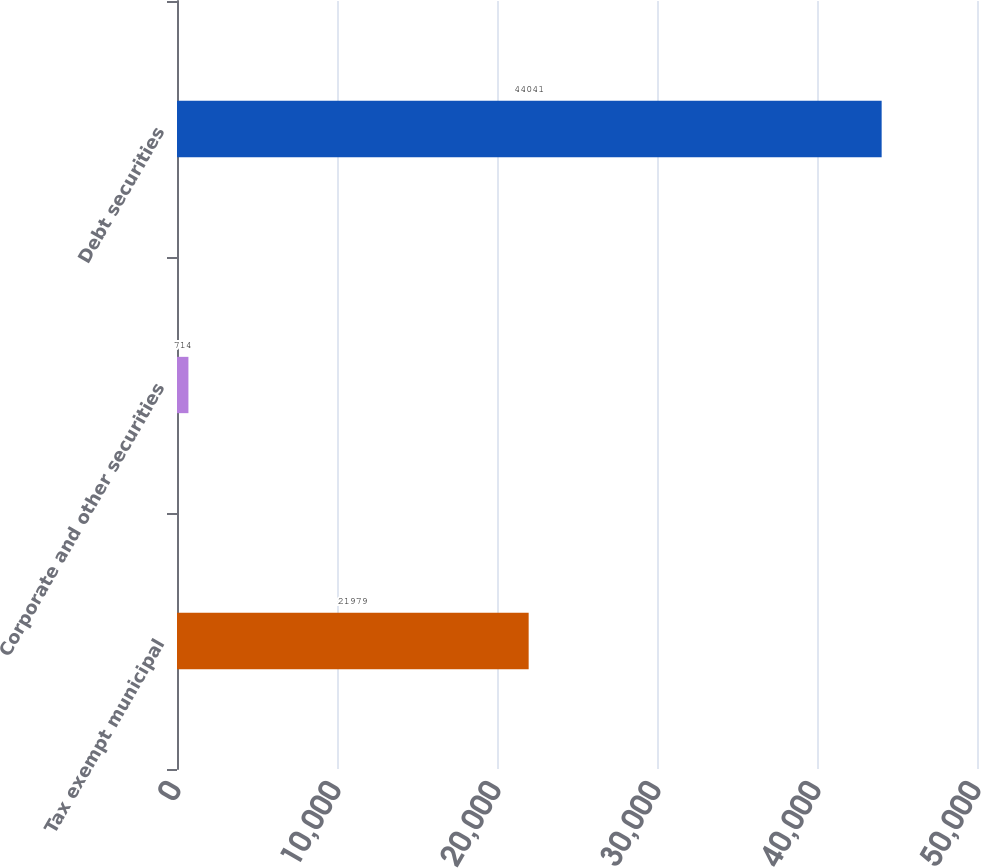Convert chart to OTSL. <chart><loc_0><loc_0><loc_500><loc_500><bar_chart><fcel>Tax exempt municipal<fcel>Corporate and other securities<fcel>Debt securities<nl><fcel>21979<fcel>714<fcel>44041<nl></chart> 